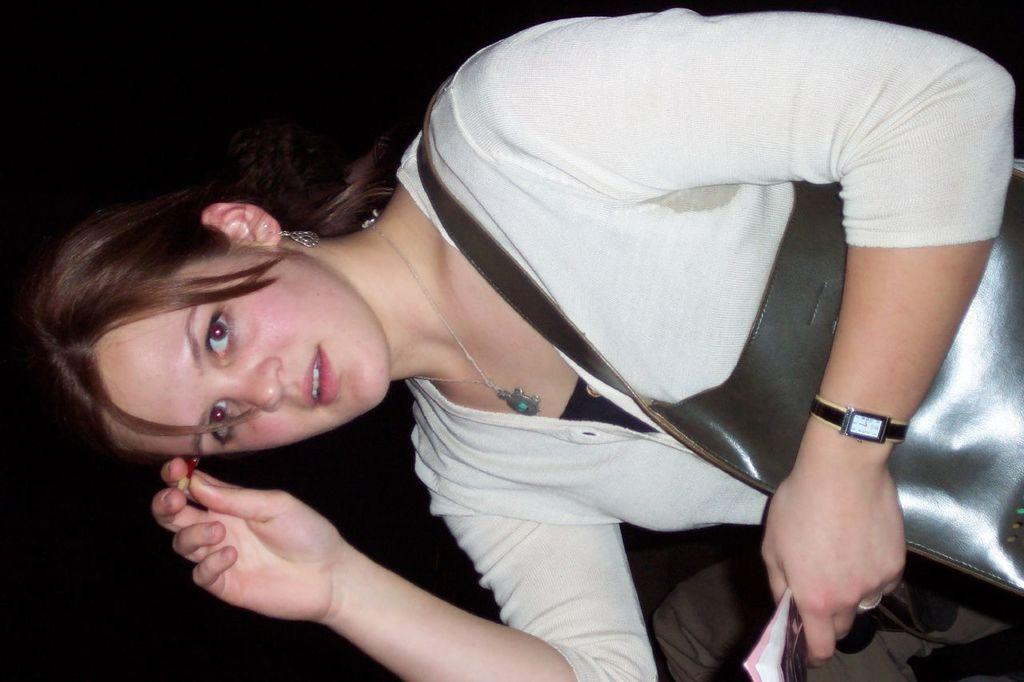Who is present in the image? There is a woman in the image. What is the woman wearing? The woman is wearing a white dress. What is the woman holding in her hand? The woman is holding an object in her hand. What color is the woman's bag? The woman has a black colored bag. What can be seen in the background of the image? The background of the image is black. What type of throne is the woman sitting on in the image? There is no throne present in the image; the woman is standing. How many potatoes can be seen in the image? There are no potatoes present in the image. 